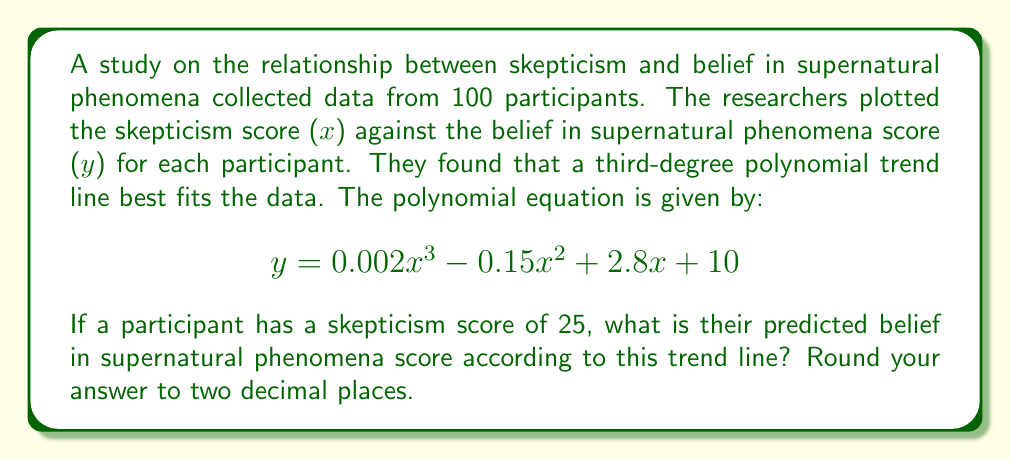Can you answer this question? To solve this problem, we need to substitute the given x-value (skepticism score) into the polynomial equation and calculate the corresponding y-value (belief in supernatural phenomena score).

Given equation: $$y = 0.002x^3 - 0.15x^2 + 2.8x + 10$$

Step 1: Substitute x = 25 into the equation
$$y = 0.002(25)^3 - 0.15(25)^2 + 2.8(25) + 10$$

Step 2: Calculate each term
1. $0.002(25)^3 = 0.002 \times 15625 = 31.25$
2. $-0.15(25)^2 = -0.15 \times 625 = -93.75$
3. $2.8(25) = 70$
4. The constant term is 10

Step 3: Sum up all terms
$$y = 31.25 - 93.75 + 70 + 10 = 17.50$$

Step 4: Round to two decimal places
$$y \approx 17.50$$

Therefore, for a skepticism score of 25, the predicted belief in supernatural phenomena score is 17.50.
Answer: 17.50 